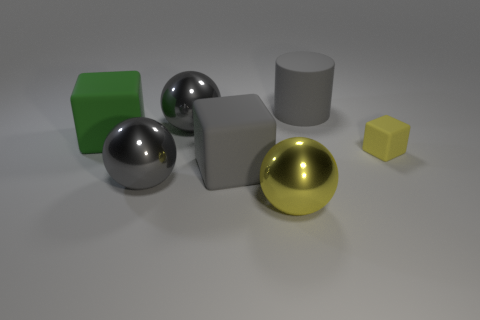Are there more green rubber things left of the large gray block than large gray cylinders?
Ensure brevity in your answer.  No. Do the large green thing and the gray matte thing that is in front of the yellow matte thing have the same shape?
Ensure brevity in your answer.  Yes. How many gray cylinders are the same size as the gray cube?
Your response must be concise. 1. There is a gray sphere that is behind the rubber block that is to the right of the yellow metal thing; how many green objects are in front of it?
Offer a terse response. 1. Is the number of big yellow shiny things that are behind the big green matte thing the same as the number of tiny yellow rubber cubes behind the large yellow metal ball?
Your answer should be compact. No. What number of other small objects are the same shape as the small object?
Keep it short and to the point. 0. Are there any green blocks that have the same material as the yellow sphere?
Provide a short and direct response. No. There is a large matte object that is the same color as the matte cylinder; what is its shape?
Your answer should be compact. Cube. How many small yellow matte blocks are there?
Provide a succinct answer. 1. What number of blocks are either big things or big gray metal objects?
Your response must be concise. 2. 